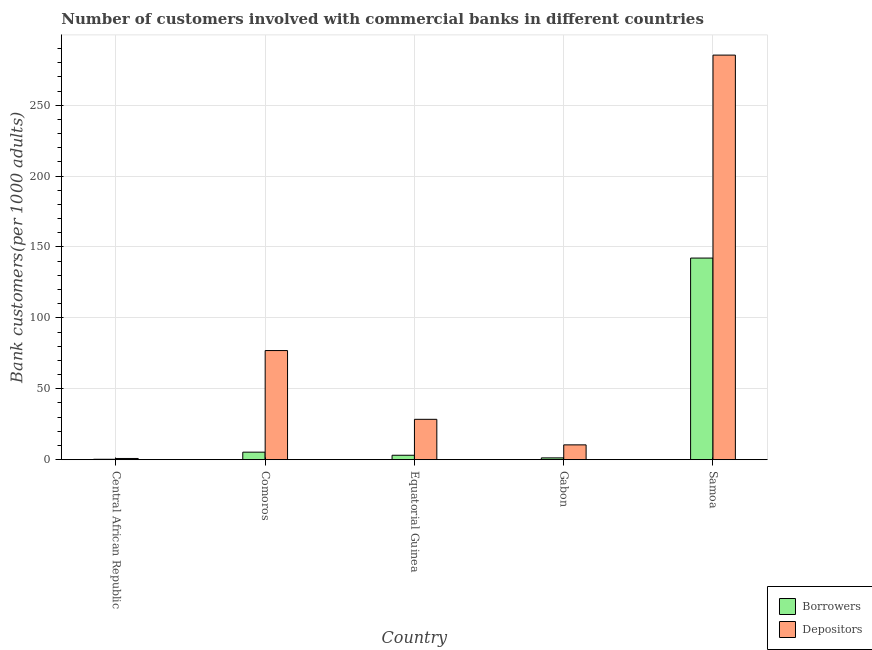How many different coloured bars are there?
Offer a very short reply. 2. How many bars are there on the 3rd tick from the left?
Make the answer very short. 2. What is the label of the 4th group of bars from the left?
Ensure brevity in your answer.  Gabon. In how many cases, is the number of bars for a given country not equal to the number of legend labels?
Provide a succinct answer. 0. What is the number of borrowers in Central African Republic?
Provide a succinct answer. 0.3. Across all countries, what is the maximum number of depositors?
Your response must be concise. 285.32. Across all countries, what is the minimum number of depositors?
Your response must be concise. 0.86. In which country was the number of depositors maximum?
Your response must be concise. Samoa. In which country was the number of depositors minimum?
Provide a succinct answer. Central African Republic. What is the total number of borrowers in the graph?
Make the answer very short. 152.21. What is the difference between the number of depositors in Equatorial Guinea and that in Samoa?
Give a very brief answer. -256.85. What is the difference between the number of borrowers in Central African Republic and the number of depositors in Equatorial Guinea?
Keep it short and to the point. -28.18. What is the average number of borrowers per country?
Provide a succinct answer. 30.44. What is the difference between the number of borrowers and number of depositors in Equatorial Guinea?
Provide a short and direct response. -25.34. In how many countries, is the number of depositors greater than 180 ?
Ensure brevity in your answer.  1. What is the ratio of the number of depositors in Central African Republic to that in Samoa?
Provide a succinct answer. 0. Is the number of borrowers in Central African Republic less than that in Gabon?
Make the answer very short. Yes. What is the difference between the highest and the second highest number of depositors?
Your answer should be very brief. 208.35. What is the difference between the highest and the lowest number of depositors?
Offer a terse response. 284.46. In how many countries, is the number of borrowers greater than the average number of borrowers taken over all countries?
Provide a succinct answer. 1. Is the sum of the number of depositors in Equatorial Guinea and Gabon greater than the maximum number of borrowers across all countries?
Make the answer very short. No. What does the 1st bar from the left in Central African Republic represents?
Your answer should be very brief. Borrowers. What does the 2nd bar from the right in Gabon represents?
Provide a succinct answer. Borrowers. How many countries are there in the graph?
Provide a short and direct response. 5. What is the difference between two consecutive major ticks on the Y-axis?
Your answer should be compact. 50. Are the values on the major ticks of Y-axis written in scientific E-notation?
Your response must be concise. No. Does the graph contain any zero values?
Offer a terse response. No. How are the legend labels stacked?
Provide a succinct answer. Vertical. What is the title of the graph?
Provide a short and direct response. Number of customers involved with commercial banks in different countries. What is the label or title of the X-axis?
Your answer should be compact. Country. What is the label or title of the Y-axis?
Provide a short and direct response. Bank customers(per 1000 adults). What is the Bank customers(per 1000 adults) in Borrowers in Central African Republic?
Offer a very short reply. 0.3. What is the Bank customers(per 1000 adults) of Depositors in Central African Republic?
Provide a succinct answer. 0.86. What is the Bank customers(per 1000 adults) in Borrowers in Comoros?
Your answer should be very brief. 5.31. What is the Bank customers(per 1000 adults) in Depositors in Comoros?
Your answer should be compact. 76.97. What is the Bank customers(per 1000 adults) in Borrowers in Equatorial Guinea?
Make the answer very short. 3.13. What is the Bank customers(per 1000 adults) in Depositors in Equatorial Guinea?
Your answer should be very brief. 28.47. What is the Bank customers(per 1000 adults) in Borrowers in Gabon?
Offer a terse response. 1.28. What is the Bank customers(per 1000 adults) in Depositors in Gabon?
Provide a short and direct response. 10.46. What is the Bank customers(per 1000 adults) in Borrowers in Samoa?
Your response must be concise. 142.19. What is the Bank customers(per 1000 adults) in Depositors in Samoa?
Provide a short and direct response. 285.32. Across all countries, what is the maximum Bank customers(per 1000 adults) in Borrowers?
Provide a succinct answer. 142.19. Across all countries, what is the maximum Bank customers(per 1000 adults) in Depositors?
Give a very brief answer. 285.32. Across all countries, what is the minimum Bank customers(per 1000 adults) of Borrowers?
Your answer should be very brief. 0.3. Across all countries, what is the minimum Bank customers(per 1000 adults) in Depositors?
Give a very brief answer. 0.86. What is the total Bank customers(per 1000 adults) of Borrowers in the graph?
Make the answer very short. 152.21. What is the total Bank customers(per 1000 adults) of Depositors in the graph?
Offer a very short reply. 402.08. What is the difference between the Bank customers(per 1000 adults) in Borrowers in Central African Republic and that in Comoros?
Give a very brief answer. -5.02. What is the difference between the Bank customers(per 1000 adults) in Depositors in Central African Republic and that in Comoros?
Offer a very short reply. -76.11. What is the difference between the Bank customers(per 1000 adults) in Borrowers in Central African Republic and that in Equatorial Guinea?
Make the answer very short. -2.84. What is the difference between the Bank customers(per 1000 adults) of Depositors in Central African Republic and that in Equatorial Guinea?
Offer a terse response. -27.62. What is the difference between the Bank customers(per 1000 adults) in Borrowers in Central African Republic and that in Gabon?
Provide a succinct answer. -0.99. What is the difference between the Bank customers(per 1000 adults) of Depositors in Central African Republic and that in Gabon?
Provide a short and direct response. -9.61. What is the difference between the Bank customers(per 1000 adults) of Borrowers in Central African Republic and that in Samoa?
Give a very brief answer. -141.89. What is the difference between the Bank customers(per 1000 adults) in Depositors in Central African Republic and that in Samoa?
Keep it short and to the point. -284.46. What is the difference between the Bank customers(per 1000 adults) of Borrowers in Comoros and that in Equatorial Guinea?
Offer a terse response. 2.18. What is the difference between the Bank customers(per 1000 adults) of Depositors in Comoros and that in Equatorial Guinea?
Give a very brief answer. 48.5. What is the difference between the Bank customers(per 1000 adults) of Borrowers in Comoros and that in Gabon?
Offer a terse response. 4.03. What is the difference between the Bank customers(per 1000 adults) in Depositors in Comoros and that in Gabon?
Give a very brief answer. 66.51. What is the difference between the Bank customers(per 1000 adults) of Borrowers in Comoros and that in Samoa?
Offer a terse response. -136.88. What is the difference between the Bank customers(per 1000 adults) of Depositors in Comoros and that in Samoa?
Offer a very short reply. -208.35. What is the difference between the Bank customers(per 1000 adults) in Borrowers in Equatorial Guinea and that in Gabon?
Offer a very short reply. 1.85. What is the difference between the Bank customers(per 1000 adults) in Depositors in Equatorial Guinea and that in Gabon?
Offer a very short reply. 18.01. What is the difference between the Bank customers(per 1000 adults) in Borrowers in Equatorial Guinea and that in Samoa?
Offer a terse response. -139.06. What is the difference between the Bank customers(per 1000 adults) of Depositors in Equatorial Guinea and that in Samoa?
Your answer should be compact. -256.85. What is the difference between the Bank customers(per 1000 adults) in Borrowers in Gabon and that in Samoa?
Make the answer very short. -140.91. What is the difference between the Bank customers(per 1000 adults) of Depositors in Gabon and that in Samoa?
Keep it short and to the point. -274.86. What is the difference between the Bank customers(per 1000 adults) of Borrowers in Central African Republic and the Bank customers(per 1000 adults) of Depositors in Comoros?
Ensure brevity in your answer.  -76.68. What is the difference between the Bank customers(per 1000 adults) of Borrowers in Central African Republic and the Bank customers(per 1000 adults) of Depositors in Equatorial Guinea?
Provide a short and direct response. -28.18. What is the difference between the Bank customers(per 1000 adults) in Borrowers in Central African Republic and the Bank customers(per 1000 adults) in Depositors in Gabon?
Your answer should be compact. -10.17. What is the difference between the Bank customers(per 1000 adults) of Borrowers in Central African Republic and the Bank customers(per 1000 adults) of Depositors in Samoa?
Provide a short and direct response. -285.02. What is the difference between the Bank customers(per 1000 adults) of Borrowers in Comoros and the Bank customers(per 1000 adults) of Depositors in Equatorial Guinea?
Offer a terse response. -23.16. What is the difference between the Bank customers(per 1000 adults) in Borrowers in Comoros and the Bank customers(per 1000 adults) in Depositors in Gabon?
Ensure brevity in your answer.  -5.15. What is the difference between the Bank customers(per 1000 adults) in Borrowers in Comoros and the Bank customers(per 1000 adults) in Depositors in Samoa?
Give a very brief answer. -280.01. What is the difference between the Bank customers(per 1000 adults) of Borrowers in Equatorial Guinea and the Bank customers(per 1000 adults) of Depositors in Gabon?
Offer a very short reply. -7.33. What is the difference between the Bank customers(per 1000 adults) of Borrowers in Equatorial Guinea and the Bank customers(per 1000 adults) of Depositors in Samoa?
Provide a short and direct response. -282.19. What is the difference between the Bank customers(per 1000 adults) in Borrowers in Gabon and the Bank customers(per 1000 adults) in Depositors in Samoa?
Offer a very short reply. -284.04. What is the average Bank customers(per 1000 adults) of Borrowers per country?
Offer a very short reply. 30.44. What is the average Bank customers(per 1000 adults) in Depositors per country?
Offer a very short reply. 80.42. What is the difference between the Bank customers(per 1000 adults) in Borrowers and Bank customers(per 1000 adults) in Depositors in Central African Republic?
Your response must be concise. -0.56. What is the difference between the Bank customers(per 1000 adults) of Borrowers and Bank customers(per 1000 adults) of Depositors in Comoros?
Your answer should be compact. -71.66. What is the difference between the Bank customers(per 1000 adults) in Borrowers and Bank customers(per 1000 adults) in Depositors in Equatorial Guinea?
Offer a terse response. -25.34. What is the difference between the Bank customers(per 1000 adults) in Borrowers and Bank customers(per 1000 adults) in Depositors in Gabon?
Offer a very short reply. -9.18. What is the difference between the Bank customers(per 1000 adults) in Borrowers and Bank customers(per 1000 adults) in Depositors in Samoa?
Provide a short and direct response. -143.13. What is the ratio of the Bank customers(per 1000 adults) in Borrowers in Central African Republic to that in Comoros?
Keep it short and to the point. 0.06. What is the ratio of the Bank customers(per 1000 adults) of Depositors in Central African Republic to that in Comoros?
Your answer should be compact. 0.01. What is the ratio of the Bank customers(per 1000 adults) of Borrowers in Central African Republic to that in Equatorial Guinea?
Your answer should be very brief. 0.09. What is the ratio of the Bank customers(per 1000 adults) of Depositors in Central African Republic to that in Equatorial Guinea?
Your response must be concise. 0.03. What is the ratio of the Bank customers(per 1000 adults) of Borrowers in Central African Republic to that in Gabon?
Provide a succinct answer. 0.23. What is the ratio of the Bank customers(per 1000 adults) of Depositors in Central African Republic to that in Gabon?
Offer a very short reply. 0.08. What is the ratio of the Bank customers(per 1000 adults) in Borrowers in Central African Republic to that in Samoa?
Offer a terse response. 0. What is the ratio of the Bank customers(per 1000 adults) of Depositors in Central African Republic to that in Samoa?
Make the answer very short. 0. What is the ratio of the Bank customers(per 1000 adults) of Borrowers in Comoros to that in Equatorial Guinea?
Provide a short and direct response. 1.7. What is the ratio of the Bank customers(per 1000 adults) of Depositors in Comoros to that in Equatorial Guinea?
Make the answer very short. 2.7. What is the ratio of the Bank customers(per 1000 adults) in Borrowers in Comoros to that in Gabon?
Your response must be concise. 4.14. What is the ratio of the Bank customers(per 1000 adults) of Depositors in Comoros to that in Gabon?
Your response must be concise. 7.36. What is the ratio of the Bank customers(per 1000 adults) in Borrowers in Comoros to that in Samoa?
Your answer should be very brief. 0.04. What is the ratio of the Bank customers(per 1000 adults) of Depositors in Comoros to that in Samoa?
Offer a very short reply. 0.27. What is the ratio of the Bank customers(per 1000 adults) of Borrowers in Equatorial Guinea to that in Gabon?
Your answer should be compact. 2.44. What is the ratio of the Bank customers(per 1000 adults) of Depositors in Equatorial Guinea to that in Gabon?
Your answer should be compact. 2.72. What is the ratio of the Bank customers(per 1000 adults) of Borrowers in Equatorial Guinea to that in Samoa?
Offer a very short reply. 0.02. What is the ratio of the Bank customers(per 1000 adults) of Depositors in Equatorial Guinea to that in Samoa?
Provide a short and direct response. 0.1. What is the ratio of the Bank customers(per 1000 adults) in Borrowers in Gabon to that in Samoa?
Keep it short and to the point. 0.01. What is the ratio of the Bank customers(per 1000 adults) in Depositors in Gabon to that in Samoa?
Ensure brevity in your answer.  0.04. What is the difference between the highest and the second highest Bank customers(per 1000 adults) in Borrowers?
Your response must be concise. 136.88. What is the difference between the highest and the second highest Bank customers(per 1000 adults) of Depositors?
Your answer should be very brief. 208.35. What is the difference between the highest and the lowest Bank customers(per 1000 adults) of Borrowers?
Your answer should be very brief. 141.89. What is the difference between the highest and the lowest Bank customers(per 1000 adults) of Depositors?
Your response must be concise. 284.46. 